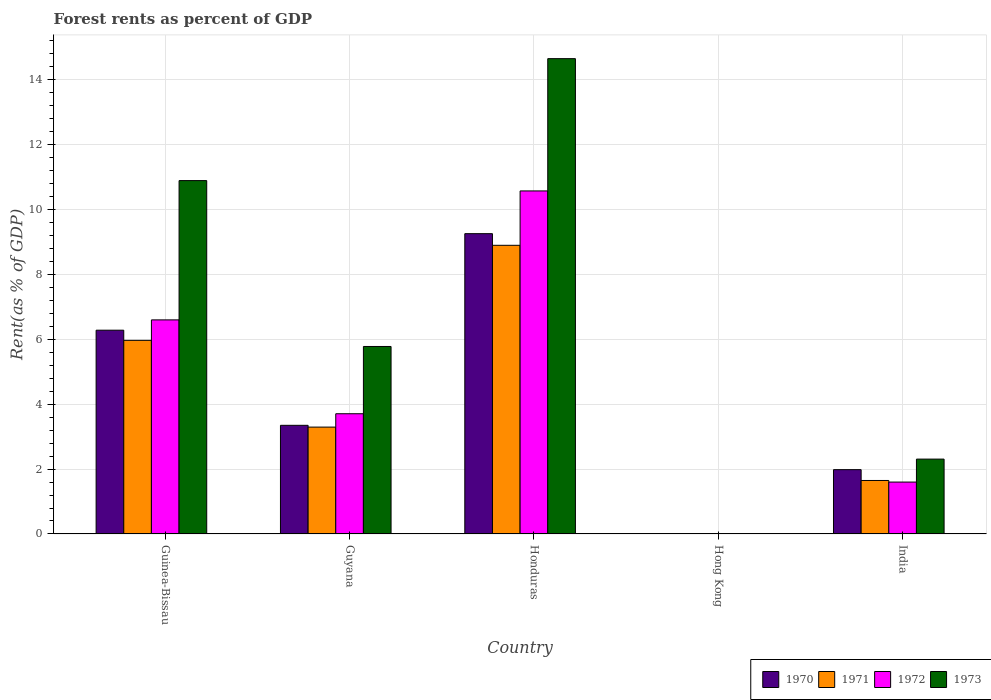How many groups of bars are there?
Provide a short and direct response. 5. Are the number of bars per tick equal to the number of legend labels?
Your response must be concise. Yes. How many bars are there on the 5th tick from the right?
Keep it short and to the point. 4. What is the label of the 5th group of bars from the left?
Your response must be concise. India. What is the forest rent in 1971 in Guyana?
Your answer should be compact. 3.29. Across all countries, what is the maximum forest rent in 1973?
Your answer should be very brief. 14.64. Across all countries, what is the minimum forest rent in 1971?
Your response must be concise. 0.01. In which country was the forest rent in 1972 maximum?
Your answer should be very brief. Honduras. In which country was the forest rent in 1973 minimum?
Keep it short and to the point. Hong Kong. What is the total forest rent in 1972 in the graph?
Provide a succinct answer. 22.47. What is the difference between the forest rent in 1970 in Honduras and that in India?
Provide a succinct answer. 7.27. What is the difference between the forest rent in 1970 in Hong Kong and the forest rent in 1973 in Honduras?
Give a very brief answer. -14.63. What is the average forest rent in 1971 per country?
Your answer should be very brief. 3.96. What is the difference between the forest rent of/in 1971 and forest rent of/in 1970 in Guinea-Bissau?
Ensure brevity in your answer.  -0.31. What is the ratio of the forest rent in 1970 in Honduras to that in Hong Kong?
Your answer should be compact. 942.83. What is the difference between the highest and the second highest forest rent in 1972?
Your answer should be compact. 6.86. What is the difference between the highest and the lowest forest rent in 1973?
Offer a very short reply. 14.63. Is it the case that in every country, the sum of the forest rent in 1970 and forest rent in 1973 is greater than the sum of forest rent in 1972 and forest rent in 1971?
Give a very brief answer. No. What does the 1st bar from the left in Honduras represents?
Make the answer very short. 1970. What does the 4th bar from the right in India represents?
Your answer should be compact. 1970. Is it the case that in every country, the sum of the forest rent in 1971 and forest rent in 1972 is greater than the forest rent in 1973?
Ensure brevity in your answer.  Yes. How many bars are there?
Provide a succinct answer. 20. Are all the bars in the graph horizontal?
Ensure brevity in your answer.  No. Are the values on the major ticks of Y-axis written in scientific E-notation?
Provide a succinct answer. No. How are the legend labels stacked?
Keep it short and to the point. Horizontal. What is the title of the graph?
Give a very brief answer. Forest rents as percent of GDP. Does "2001" appear as one of the legend labels in the graph?
Offer a terse response. No. What is the label or title of the X-axis?
Your answer should be compact. Country. What is the label or title of the Y-axis?
Offer a very short reply. Rent(as % of GDP). What is the Rent(as % of GDP) in 1970 in Guinea-Bissau?
Keep it short and to the point. 6.28. What is the Rent(as % of GDP) of 1971 in Guinea-Bissau?
Your response must be concise. 5.97. What is the Rent(as % of GDP) of 1972 in Guinea-Bissau?
Your answer should be compact. 6.6. What is the Rent(as % of GDP) in 1973 in Guinea-Bissau?
Your answer should be compact. 10.89. What is the Rent(as % of GDP) of 1970 in Guyana?
Give a very brief answer. 3.35. What is the Rent(as % of GDP) in 1971 in Guyana?
Your response must be concise. 3.29. What is the Rent(as % of GDP) of 1972 in Guyana?
Ensure brevity in your answer.  3.7. What is the Rent(as % of GDP) of 1973 in Guyana?
Your response must be concise. 5.78. What is the Rent(as % of GDP) of 1970 in Honduras?
Offer a very short reply. 9.25. What is the Rent(as % of GDP) of 1971 in Honduras?
Make the answer very short. 8.89. What is the Rent(as % of GDP) of 1972 in Honduras?
Keep it short and to the point. 10.57. What is the Rent(as % of GDP) in 1973 in Honduras?
Your answer should be very brief. 14.64. What is the Rent(as % of GDP) in 1970 in Hong Kong?
Give a very brief answer. 0.01. What is the Rent(as % of GDP) in 1971 in Hong Kong?
Make the answer very short. 0.01. What is the Rent(as % of GDP) of 1972 in Hong Kong?
Keep it short and to the point. 0.01. What is the Rent(as % of GDP) of 1973 in Hong Kong?
Offer a terse response. 0.01. What is the Rent(as % of GDP) in 1970 in India?
Your answer should be very brief. 1.98. What is the Rent(as % of GDP) in 1971 in India?
Ensure brevity in your answer.  1.65. What is the Rent(as % of GDP) in 1972 in India?
Your answer should be compact. 1.6. What is the Rent(as % of GDP) of 1973 in India?
Your answer should be compact. 2.31. Across all countries, what is the maximum Rent(as % of GDP) of 1970?
Your response must be concise. 9.25. Across all countries, what is the maximum Rent(as % of GDP) of 1971?
Keep it short and to the point. 8.89. Across all countries, what is the maximum Rent(as % of GDP) in 1972?
Keep it short and to the point. 10.57. Across all countries, what is the maximum Rent(as % of GDP) in 1973?
Make the answer very short. 14.64. Across all countries, what is the minimum Rent(as % of GDP) of 1970?
Offer a terse response. 0.01. Across all countries, what is the minimum Rent(as % of GDP) in 1971?
Make the answer very short. 0.01. Across all countries, what is the minimum Rent(as % of GDP) in 1972?
Your response must be concise. 0.01. Across all countries, what is the minimum Rent(as % of GDP) of 1973?
Offer a terse response. 0.01. What is the total Rent(as % of GDP) of 1970 in the graph?
Your answer should be compact. 20.87. What is the total Rent(as % of GDP) of 1971 in the graph?
Give a very brief answer. 19.81. What is the total Rent(as % of GDP) of 1972 in the graph?
Ensure brevity in your answer.  22.47. What is the total Rent(as % of GDP) of 1973 in the graph?
Offer a terse response. 33.62. What is the difference between the Rent(as % of GDP) in 1970 in Guinea-Bissau and that in Guyana?
Make the answer very short. 2.93. What is the difference between the Rent(as % of GDP) of 1971 in Guinea-Bissau and that in Guyana?
Offer a very short reply. 2.67. What is the difference between the Rent(as % of GDP) of 1972 in Guinea-Bissau and that in Guyana?
Give a very brief answer. 2.89. What is the difference between the Rent(as % of GDP) in 1973 in Guinea-Bissau and that in Guyana?
Your response must be concise. 5.11. What is the difference between the Rent(as % of GDP) in 1970 in Guinea-Bissau and that in Honduras?
Your answer should be compact. -2.97. What is the difference between the Rent(as % of GDP) of 1971 in Guinea-Bissau and that in Honduras?
Offer a very short reply. -2.93. What is the difference between the Rent(as % of GDP) in 1972 in Guinea-Bissau and that in Honduras?
Your answer should be very brief. -3.97. What is the difference between the Rent(as % of GDP) in 1973 in Guinea-Bissau and that in Honduras?
Give a very brief answer. -3.76. What is the difference between the Rent(as % of GDP) of 1970 in Guinea-Bissau and that in Hong Kong?
Provide a short and direct response. 6.27. What is the difference between the Rent(as % of GDP) in 1971 in Guinea-Bissau and that in Hong Kong?
Make the answer very short. 5.96. What is the difference between the Rent(as % of GDP) in 1972 in Guinea-Bissau and that in Hong Kong?
Make the answer very short. 6.59. What is the difference between the Rent(as % of GDP) in 1973 in Guinea-Bissau and that in Hong Kong?
Offer a very short reply. 10.88. What is the difference between the Rent(as % of GDP) of 1970 in Guinea-Bissau and that in India?
Your answer should be very brief. 4.3. What is the difference between the Rent(as % of GDP) in 1971 in Guinea-Bissau and that in India?
Give a very brief answer. 4.32. What is the difference between the Rent(as % of GDP) of 1972 in Guinea-Bissau and that in India?
Keep it short and to the point. 5. What is the difference between the Rent(as % of GDP) of 1973 in Guinea-Bissau and that in India?
Keep it short and to the point. 8.58. What is the difference between the Rent(as % of GDP) in 1970 in Guyana and that in Honduras?
Offer a very short reply. -5.9. What is the difference between the Rent(as % of GDP) in 1971 in Guyana and that in Honduras?
Make the answer very short. -5.6. What is the difference between the Rent(as % of GDP) of 1972 in Guyana and that in Honduras?
Provide a short and direct response. -6.86. What is the difference between the Rent(as % of GDP) of 1973 in Guyana and that in Honduras?
Give a very brief answer. -8.87. What is the difference between the Rent(as % of GDP) of 1970 in Guyana and that in Hong Kong?
Give a very brief answer. 3.34. What is the difference between the Rent(as % of GDP) in 1971 in Guyana and that in Hong Kong?
Give a very brief answer. 3.29. What is the difference between the Rent(as % of GDP) in 1972 in Guyana and that in Hong Kong?
Ensure brevity in your answer.  3.7. What is the difference between the Rent(as % of GDP) of 1973 in Guyana and that in Hong Kong?
Provide a succinct answer. 5.77. What is the difference between the Rent(as % of GDP) in 1970 in Guyana and that in India?
Your answer should be compact. 1.37. What is the difference between the Rent(as % of GDP) of 1971 in Guyana and that in India?
Provide a succinct answer. 1.64. What is the difference between the Rent(as % of GDP) of 1972 in Guyana and that in India?
Offer a very short reply. 2.11. What is the difference between the Rent(as % of GDP) of 1973 in Guyana and that in India?
Make the answer very short. 3.47. What is the difference between the Rent(as % of GDP) in 1970 in Honduras and that in Hong Kong?
Ensure brevity in your answer.  9.24. What is the difference between the Rent(as % of GDP) of 1971 in Honduras and that in Hong Kong?
Keep it short and to the point. 8.89. What is the difference between the Rent(as % of GDP) of 1972 in Honduras and that in Hong Kong?
Offer a very short reply. 10.56. What is the difference between the Rent(as % of GDP) in 1973 in Honduras and that in Hong Kong?
Make the answer very short. 14.63. What is the difference between the Rent(as % of GDP) in 1970 in Honduras and that in India?
Your answer should be very brief. 7.27. What is the difference between the Rent(as % of GDP) of 1971 in Honduras and that in India?
Provide a succinct answer. 7.24. What is the difference between the Rent(as % of GDP) of 1972 in Honduras and that in India?
Ensure brevity in your answer.  8.97. What is the difference between the Rent(as % of GDP) in 1973 in Honduras and that in India?
Provide a short and direct response. 12.34. What is the difference between the Rent(as % of GDP) of 1970 in Hong Kong and that in India?
Your answer should be very brief. -1.97. What is the difference between the Rent(as % of GDP) of 1971 in Hong Kong and that in India?
Your answer should be very brief. -1.64. What is the difference between the Rent(as % of GDP) of 1972 in Hong Kong and that in India?
Provide a succinct answer. -1.59. What is the difference between the Rent(as % of GDP) in 1973 in Hong Kong and that in India?
Your answer should be very brief. -2.3. What is the difference between the Rent(as % of GDP) in 1970 in Guinea-Bissau and the Rent(as % of GDP) in 1971 in Guyana?
Provide a succinct answer. 2.99. What is the difference between the Rent(as % of GDP) of 1970 in Guinea-Bissau and the Rent(as % of GDP) of 1972 in Guyana?
Provide a short and direct response. 2.57. What is the difference between the Rent(as % of GDP) in 1970 in Guinea-Bissau and the Rent(as % of GDP) in 1973 in Guyana?
Offer a terse response. 0.5. What is the difference between the Rent(as % of GDP) in 1971 in Guinea-Bissau and the Rent(as % of GDP) in 1972 in Guyana?
Offer a terse response. 2.26. What is the difference between the Rent(as % of GDP) of 1971 in Guinea-Bissau and the Rent(as % of GDP) of 1973 in Guyana?
Give a very brief answer. 0.19. What is the difference between the Rent(as % of GDP) in 1972 in Guinea-Bissau and the Rent(as % of GDP) in 1973 in Guyana?
Provide a short and direct response. 0.82. What is the difference between the Rent(as % of GDP) in 1970 in Guinea-Bissau and the Rent(as % of GDP) in 1971 in Honduras?
Make the answer very short. -2.62. What is the difference between the Rent(as % of GDP) of 1970 in Guinea-Bissau and the Rent(as % of GDP) of 1972 in Honduras?
Your response must be concise. -4.29. What is the difference between the Rent(as % of GDP) of 1970 in Guinea-Bissau and the Rent(as % of GDP) of 1973 in Honduras?
Provide a short and direct response. -8.37. What is the difference between the Rent(as % of GDP) in 1971 in Guinea-Bissau and the Rent(as % of GDP) in 1972 in Honduras?
Your answer should be compact. -4.6. What is the difference between the Rent(as % of GDP) in 1971 in Guinea-Bissau and the Rent(as % of GDP) in 1973 in Honduras?
Offer a very short reply. -8.68. What is the difference between the Rent(as % of GDP) in 1972 in Guinea-Bissau and the Rent(as % of GDP) in 1973 in Honduras?
Provide a short and direct response. -8.05. What is the difference between the Rent(as % of GDP) in 1970 in Guinea-Bissau and the Rent(as % of GDP) in 1971 in Hong Kong?
Ensure brevity in your answer.  6.27. What is the difference between the Rent(as % of GDP) of 1970 in Guinea-Bissau and the Rent(as % of GDP) of 1972 in Hong Kong?
Provide a succinct answer. 6.27. What is the difference between the Rent(as % of GDP) in 1970 in Guinea-Bissau and the Rent(as % of GDP) in 1973 in Hong Kong?
Ensure brevity in your answer.  6.27. What is the difference between the Rent(as % of GDP) in 1971 in Guinea-Bissau and the Rent(as % of GDP) in 1972 in Hong Kong?
Make the answer very short. 5.96. What is the difference between the Rent(as % of GDP) in 1971 in Guinea-Bissau and the Rent(as % of GDP) in 1973 in Hong Kong?
Your answer should be very brief. 5.95. What is the difference between the Rent(as % of GDP) of 1972 in Guinea-Bissau and the Rent(as % of GDP) of 1973 in Hong Kong?
Your response must be concise. 6.58. What is the difference between the Rent(as % of GDP) in 1970 in Guinea-Bissau and the Rent(as % of GDP) in 1971 in India?
Your response must be concise. 4.63. What is the difference between the Rent(as % of GDP) in 1970 in Guinea-Bissau and the Rent(as % of GDP) in 1972 in India?
Provide a succinct answer. 4.68. What is the difference between the Rent(as % of GDP) of 1970 in Guinea-Bissau and the Rent(as % of GDP) of 1973 in India?
Make the answer very short. 3.97. What is the difference between the Rent(as % of GDP) in 1971 in Guinea-Bissau and the Rent(as % of GDP) in 1972 in India?
Your response must be concise. 4.37. What is the difference between the Rent(as % of GDP) of 1971 in Guinea-Bissau and the Rent(as % of GDP) of 1973 in India?
Provide a short and direct response. 3.66. What is the difference between the Rent(as % of GDP) of 1972 in Guinea-Bissau and the Rent(as % of GDP) of 1973 in India?
Offer a very short reply. 4.29. What is the difference between the Rent(as % of GDP) of 1970 in Guyana and the Rent(as % of GDP) of 1971 in Honduras?
Provide a short and direct response. -5.55. What is the difference between the Rent(as % of GDP) of 1970 in Guyana and the Rent(as % of GDP) of 1972 in Honduras?
Give a very brief answer. -7.22. What is the difference between the Rent(as % of GDP) in 1970 in Guyana and the Rent(as % of GDP) in 1973 in Honduras?
Keep it short and to the point. -11.3. What is the difference between the Rent(as % of GDP) of 1971 in Guyana and the Rent(as % of GDP) of 1972 in Honduras?
Your answer should be very brief. -7.28. What is the difference between the Rent(as % of GDP) of 1971 in Guyana and the Rent(as % of GDP) of 1973 in Honduras?
Your response must be concise. -11.35. What is the difference between the Rent(as % of GDP) of 1972 in Guyana and the Rent(as % of GDP) of 1973 in Honduras?
Keep it short and to the point. -10.94. What is the difference between the Rent(as % of GDP) in 1970 in Guyana and the Rent(as % of GDP) in 1971 in Hong Kong?
Make the answer very short. 3.34. What is the difference between the Rent(as % of GDP) of 1970 in Guyana and the Rent(as % of GDP) of 1972 in Hong Kong?
Offer a terse response. 3.34. What is the difference between the Rent(as % of GDP) of 1970 in Guyana and the Rent(as % of GDP) of 1973 in Hong Kong?
Give a very brief answer. 3.34. What is the difference between the Rent(as % of GDP) of 1971 in Guyana and the Rent(as % of GDP) of 1972 in Hong Kong?
Provide a short and direct response. 3.29. What is the difference between the Rent(as % of GDP) in 1971 in Guyana and the Rent(as % of GDP) in 1973 in Hong Kong?
Provide a short and direct response. 3.28. What is the difference between the Rent(as % of GDP) of 1972 in Guyana and the Rent(as % of GDP) of 1973 in Hong Kong?
Your response must be concise. 3.69. What is the difference between the Rent(as % of GDP) in 1970 in Guyana and the Rent(as % of GDP) in 1971 in India?
Your answer should be very brief. 1.7. What is the difference between the Rent(as % of GDP) in 1970 in Guyana and the Rent(as % of GDP) in 1972 in India?
Your answer should be compact. 1.75. What is the difference between the Rent(as % of GDP) of 1970 in Guyana and the Rent(as % of GDP) of 1973 in India?
Offer a terse response. 1.04. What is the difference between the Rent(as % of GDP) of 1971 in Guyana and the Rent(as % of GDP) of 1972 in India?
Ensure brevity in your answer.  1.69. What is the difference between the Rent(as % of GDP) of 1971 in Guyana and the Rent(as % of GDP) of 1973 in India?
Offer a very short reply. 0.99. What is the difference between the Rent(as % of GDP) of 1972 in Guyana and the Rent(as % of GDP) of 1973 in India?
Your answer should be compact. 1.4. What is the difference between the Rent(as % of GDP) in 1970 in Honduras and the Rent(as % of GDP) in 1971 in Hong Kong?
Offer a very short reply. 9.25. What is the difference between the Rent(as % of GDP) of 1970 in Honduras and the Rent(as % of GDP) of 1972 in Hong Kong?
Your response must be concise. 9.25. What is the difference between the Rent(as % of GDP) of 1970 in Honduras and the Rent(as % of GDP) of 1973 in Hong Kong?
Keep it short and to the point. 9.24. What is the difference between the Rent(as % of GDP) of 1971 in Honduras and the Rent(as % of GDP) of 1972 in Hong Kong?
Offer a terse response. 8.89. What is the difference between the Rent(as % of GDP) of 1971 in Honduras and the Rent(as % of GDP) of 1973 in Hong Kong?
Provide a succinct answer. 8.88. What is the difference between the Rent(as % of GDP) in 1972 in Honduras and the Rent(as % of GDP) in 1973 in Hong Kong?
Your answer should be very brief. 10.56. What is the difference between the Rent(as % of GDP) of 1970 in Honduras and the Rent(as % of GDP) of 1971 in India?
Ensure brevity in your answer.  7.6. What is the difference between the Rent(as % of GDP) of 1970 in Honduras and the Rent(as % of GDP) of 1972 in India?
Provide a succinct answer. 7.65. What is the difference between the Rent(as % of GDP) in 1970 in Honduras and the Rent(as % of GDP) in 1973 in India?
Give a very brief answer. 6.95. What is the difference between the Rent(as % of GDP) in 1971 in Honduras and the Rent(as % of GDP) in 1972 in India?
Provide a short and direct response. 7.29. What is the difference between the Rent(as % of GDP) in 1971 in Honduras and the Rent(as % of GDP) in 1973 in India?
Your response must be concise. 6.59. What is the difference between the Rent(as % of GDP) of 1972 in Honduras and the Rent(as % of GDP) of 1973 in India?
Make the answer very short. 8.26. What is the difference between the Rent(as % of GDP) in 1970 in Hong Kong and the Rent(as % of GDP) in 1971 in India?
Keep it short and to the point. -1.64. What is the difference between the Rent(as % of GDP) of 1970 in Hong Kong and the Rent(as % of GDP) of 1972 in India?
Ensure brevity in your answer.  -1.59. What is the difference between the Rent(as % of GDP) of 1970 in Hong Kong and the Rent(as % of GDP) of 1973 in India?
Your answer should be compact. -2.3. What is the difference between the Rent(as % of GDP) in 1971 in Hong Kong and the Rent(as % of GDP) in 1972 in India?
Your response must be concise. -1.59. What is the difference between the Rent(as % of GDP) of 1971 in Hong Kong and the Rent(as % of GDP) of 1973 in India?
Give a very brief answer. -2.3. What is the difference between the Rent(as % of GDP) of 1972 in Hong Kong and the Rent(as % of GDP) of 1973 in India?
Offer a terse response. -2.3. What is the average Rent(as % of GDP) in 1970 per country?
Provide a short and direct response. 4.17. What is the average Rent(as % of GDP) in 1971 per country?
Offer a terse response. 3.96. What is the average Rent(as % of GDP) of 1972 per country?
Your response must be concise. 4.49. What is the average Rent(as % of GDP) of 1973 per country?
Provide a short and direct response. 6.72. What is the difference between the Rent(as % of GDP) in 1970 and Rent(as % of GDP) in 1971 in Guinea-Bissau?
Make the answer very short. 0.31. What is the difference between the Rent(as % of GDP) in 1970 and Rent(as % of GDP) in 1972 in Guinea-Bissau?
Provide a succinct answer. -0.32. What is the difference between the Rent(as % of GDP) in 1970 and Rent(as % of GDP) in 1973 in Guinea-Bissau?
Offer a very short reply. -4.61. What is the difference between the Rent(as % of GDP) of 1971 and Rent(as % of GDP) of 1972 in Guinea-Bissau?
Your response must be concise. -0.63. What is the difference between the Rent(as % of GDP) in 1971 and Rent(as % of GDP) in 1973 in Guinea-Bissau?
Offer a very short reply. -4.92. What is the difference between the Rent(as % of GDP) in 1972 and Rent(as % of GDP) in 1973 in Guinea-Bissau?
Keep it short and to the point. -4.29. What is the difference between the Rent(as % of GDP) of 1970 and Rent(as % of GDP) of 1971 in Guyana?
Your response must be concise. 0.05. What is the difference between the Rent(as % of GDP) of 1970 and Rent(as % of GDP) of 1972 in Guyana?
Keep it short and to the point. -0.36. What is the difference between the Rent(as % of GDP) in 1970 and Rent(as % of GDP) in 1973 in Guyana?
Provide a succinct answer. -2.43. What is the difference between the Rent(as % of GDP) in 1971 and Rent(as % of GDP) in 1972 in Guyana?
Your response must be concise. -0.41. What is the difference between the Rent(as % of GDP) in 1971 and Rent(as % of GDP) in 1973 in Guyana?
Give a very brief answer. -2.48. What is the difference between the Rent(as % of GDP) in 1972 and Rent(as % of GDP) in 1973 in Guyana?
Your answer should be compact. -2.07. What is the difference between the Rent(as % of GDP) in 1970 and Rent(as % of GDP) in 1971 in Honduras?
Provide a short and direct response. 0.36. What is the difference between the Rent(as % of GDP) of 1970 and Rent(as % of GDP) of 1972 in Honduras?
Make the answer very short. -1.32. What is the difference between the Rent(as % of GDP) of 1970 and Rent(as % of GDP) of 1973 in Honduras?
Provide a short and direct response. -5.39. What is the difference between the Rent(as % of GDP) in 1971 and Rent(as % of GDP) in 1972 in Honduras?
Provide a short and direct response. -1.67. What is the difference between the Rent(as % of GDP) of 1971 and Rent(as % of GDP) of 1973 in Honduras?
Give a very brief answer. -5.75. What is the difference between the Rent(as % of GDP) in 1972 and Rent(as % of GDP) in 1973 in Honduras?
Offer a very short reply. -4.08. What is the difference between the Rent(as % of GDP) of 1970 and Rent(as % of GDP) of 1971 in Hong Kong?
Provide a succinct answer. 0. What is the difference between the Rent(as % of GDP) in 1970 and Rent(as % of GDP) in 1972 in Hong Kong?
Provide a succinct answer. 0. What is the difference between the Rent(as % of GDP) of 1970 and Rent(as % of GDP) of 1973 in Hong Kong?
Your answer should be very brief. -0. What is the difference between the Rent(as % of GDP) of 1971 and Rent(as % of GDP) of 1972 in Hong Kong?
Offer a terse response. 0. What is the difference between the Rent(as % of GDP) in 1971 and Rent(as % of GDP) in 1973 in Hong Kong?
Give a very brief answer. -0. What is the difference between the Rent(as % of GDP) in 1972 and Rent(as % of GDP) in 1973 in Hong Kong?
Your answer should be very brief. -0. What is the difference between the Rent(as % of GDP) in 1970 and Rent(as % of GDP) in 1971 in India?
Provide a succinct answer. 0.33. What is the difference between the Rent(as % of GDP) of 1970 and Rent(as % of GDP) of 1972 in India?
Your answer should be compact. 0.38. What is the difference between the Rent(as % of GDP) in 1970 and Rent(as % of GDP) in 1973 in India?
Your answer should be very brief. -0.32. What is the difference between the Rent(as % of GDP) of 1971 and Rent(as % of GDP) of 1972 in India?
Offer a very short reply. 0.05. What is the difference between the Rent(as % of GDP) in 1971 and Rent(as % of GDP) in 1973 in India?
Give a very brief answer. -0.66. What is the difference between the Rent(as % of GDP) in 1972 and Rent(as % of GDP) in 1973 in India?
Offer a terse response. -0.71. What is the ratio of the Rent(as % of GDP) in 1970 in Guinea-Bissau to that in Guyana?
Make the answer very short. 1.88. What is the ratio of the Rent(as % of GDP) of 1971 in Guinea-Bissau to that in Guyana?
Ensure brevity in your answer.  1.81. What is the ratio of the Rent(as % of GDP) of 1972 in Guinea-Bissau to that in Guyana?
Ensure brevity in your answer.  1.78. What is the ratio of the Rent(as % of GDP) in 1973 in Guinea-Bissau to that in Guyana?
Keep it short and to the point. 1.88. What is the ratio of the Rent(as % of GDP) in 1970 in Guinea-Bissau to that in Honduras?
Your answer should be very brief. 0.68. What is the ratio of the Rent(as % of GDP) in 1971 in Guinea-Bissau to that in Honduras?
Keep it short and to the point. 0.67. What is the ratio of the Rent(as % of GDP) of 1972 in Guinea-Bissau to that in Honduras?
Keep it short and to the point. 0.62. What is the ratio of the Rent(as % of GDP) in 1973 in Guinea-Bissau to that in Honduras?
Give a very brief answer. 0.74. What is the ratio of the Rent(as % of GDP) of 1970 in Guinea-Bissau to that in Hong Kong?
Give a very brief answer. 639.74. What is the ratio of the Rent(as % of GDP) of 1971 in Guinea-Bissau to that in Hong Kong?
Your answer should be very brief. 907.52. What is the ratio of the Rent(as % of GDP) in 1972 in Guinea-Bissau to that in Hong Kong?
Make the answer very short. 1022.94. What is the ratio of the Rent(as % of GDP) in 1973 in Guinea-Bissau to that in Hong Kong?
Give a very brief answer. 1008.57. What is the ratio of the Rent(as % of GDP) of 1970 in Guinea-Bissau to that in India?
Offer a very short reply. 3.17. What is the ratio of the Rent(as % of GDP) in 1971 in Guinea-Bissau to that in India?
Provide a short and direct response. 3.62. What is the ratio of the Rent(as % of GDP) of 1972 in Guinea-Bissau to that in India?
Provide a short and direct response. 4.12. What is the ratio of the Rent(as % of GDP) in 1973 in Guinea-Bissau to that in India?
Your response must be concise. 4.72. What is the ratio of the Rent(as % of GDP) in 1970 in Guyana to that in Honduras?
Give a very brief answer. 0.36. What is the ratio of the Rent(as % of GDP) of 1971 in Guyana to that in Honduras?
Offer a very short reply. 0.37. What is the ratio of the Rent(as % of GDP) in 1972 in Guyana to that in Honduras?
Make the answer very short. 0.35. What is the ratio of the Rent(as % of GDP) in 1973 in Guyana to that in Honduras?
Offer a terse response. 0.39. What is the ratio of the Rent(as % of GDP) of 1970 in Guyana to that in Hong Kong?
Make the answer very short. 341.1. What is the ratio of the Rent(as % of GDP) of 1971 in Guyana to that in Hong Kong?
Provide a short and direct response. 500.92. What is the ratio of the Rent(as % of GDP) of 1972 in Guyana to that in Hong Kong?
Make the answer very short. 574.53. What is the ratio of the Rent(as % of GDP) of 1973 in Guyana to that in Hong Kong?
Provide a succinct answer. 535.14. What is the ratio of the Rent(as % of GDP) of 1970 in Guyana to that in India?
Provide a succinct answer. 1.69. What is the ratio of the Rent(as % of GDP) in 1971 in Guyana to that in India?
Your response must be concise. 2. What is the ratio of the Rent(as % of GDP) in 1972 in Guyana to that in India?
Provide a succinct answer. 2.32. What is the ratio of the Rent(as % of GDP) of 1973 in Guyana to that in India?
Provide a succinct answer. 2.5. What is the ratio of the Rent(as % of GDP) of 1970 in Honduras to that in Hong Kong?
Give a very brief answer. 942.83. What is the ratio of the Rent(as % of GDP) in 1971 in Honduras to that in Hong Kong?
Your answer should be compact. 1352.94. What is the ratio of the Rent(as % of GDP) of 1972 in Honduras to that in Hong Kong?
Give a very brief answer. 1639.07. What is the ratio of the Rent(as % of GDP) of 1973 in Honduras to that in Hong Kong?
Keep it short and to the point. 1356.64. What is the ratio of the Rent(as % of GDP) of 1970 in Honduras to that in India?
Your response must be concise. 4.67. What is the ratio of the Rent(as % of GDP) in 1971 in Honduras to that in India?
Your answer should be compact. 5.4. What is the ratio of the Rent(as % of GDP) of 1972 in Honduras to that in India?
Provide a succinct answer. 6.61. What is the ratio of the Rent(as % of GDP) of 1973 in Honduras to that in India?
Provide a short and direct response. 6.35. What is the ratio of the Rent(as % of GDP) of 1970 in Hong Kong to that in India?
Provide a short and direct response. 0.01. What is the ratio of the Rent(as % of GDP) in 1971 in Hong Kong to that in India?
Give a very brief answer. 0. What is the ratio of the Rent(as % of GDP) of 1972 in Hong Kong to that in India?
Offer a very short reply. 0. What is the ratio of the Rent(as % of GDP) in 1973 in Hong Kong to that in India?
Your answer should be very brief. 0. What is the difference between the highest and the second highest Rent(as % of GDP) in 1970?
Your response must be concise. 2.97. What is the difference between the highest and the second highest Rent(as % of GDP) of 1971?
Offer a terse response. 2.93. What is the difference between the highest and the second highest Rent(as % of GDP) of 1972?
Make the answer very short. 3.97. What is the difference between the highest and the second highest Rent(as % of GDP) in 1973?
Your answer should be compact. 3.76. What is the difference between the highest and the lowest Rent(as % of GDP) in 1970?
Give a very brief answer. 9.24. What is the difference between the highest and the lowest Rent(as % of GDP) in 1971?
Offer a terse response. 8.89. What is the difference between the highest and the lowest Rent(as % of GDP) of 1972?
Your response must be concise. 10.56. What is the difference between the highest and the lowest Rent(as % of GDP) of 1973?
Make the answer very short. 14.63. 